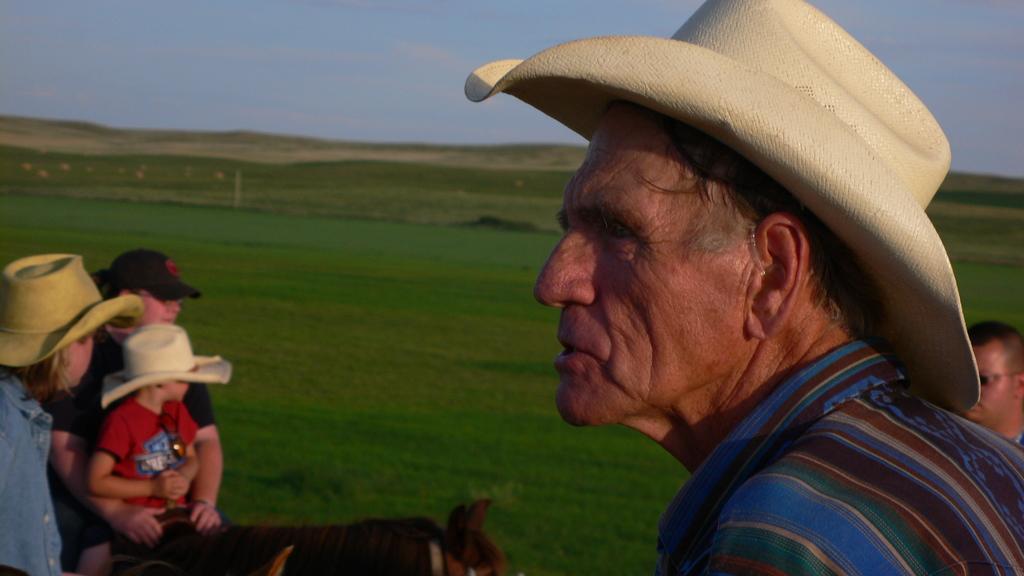Can you describe this image briefly? A man with hat looking aside. A girl with a child is riding a horse. There is man behind. There are grass patches at the background. 